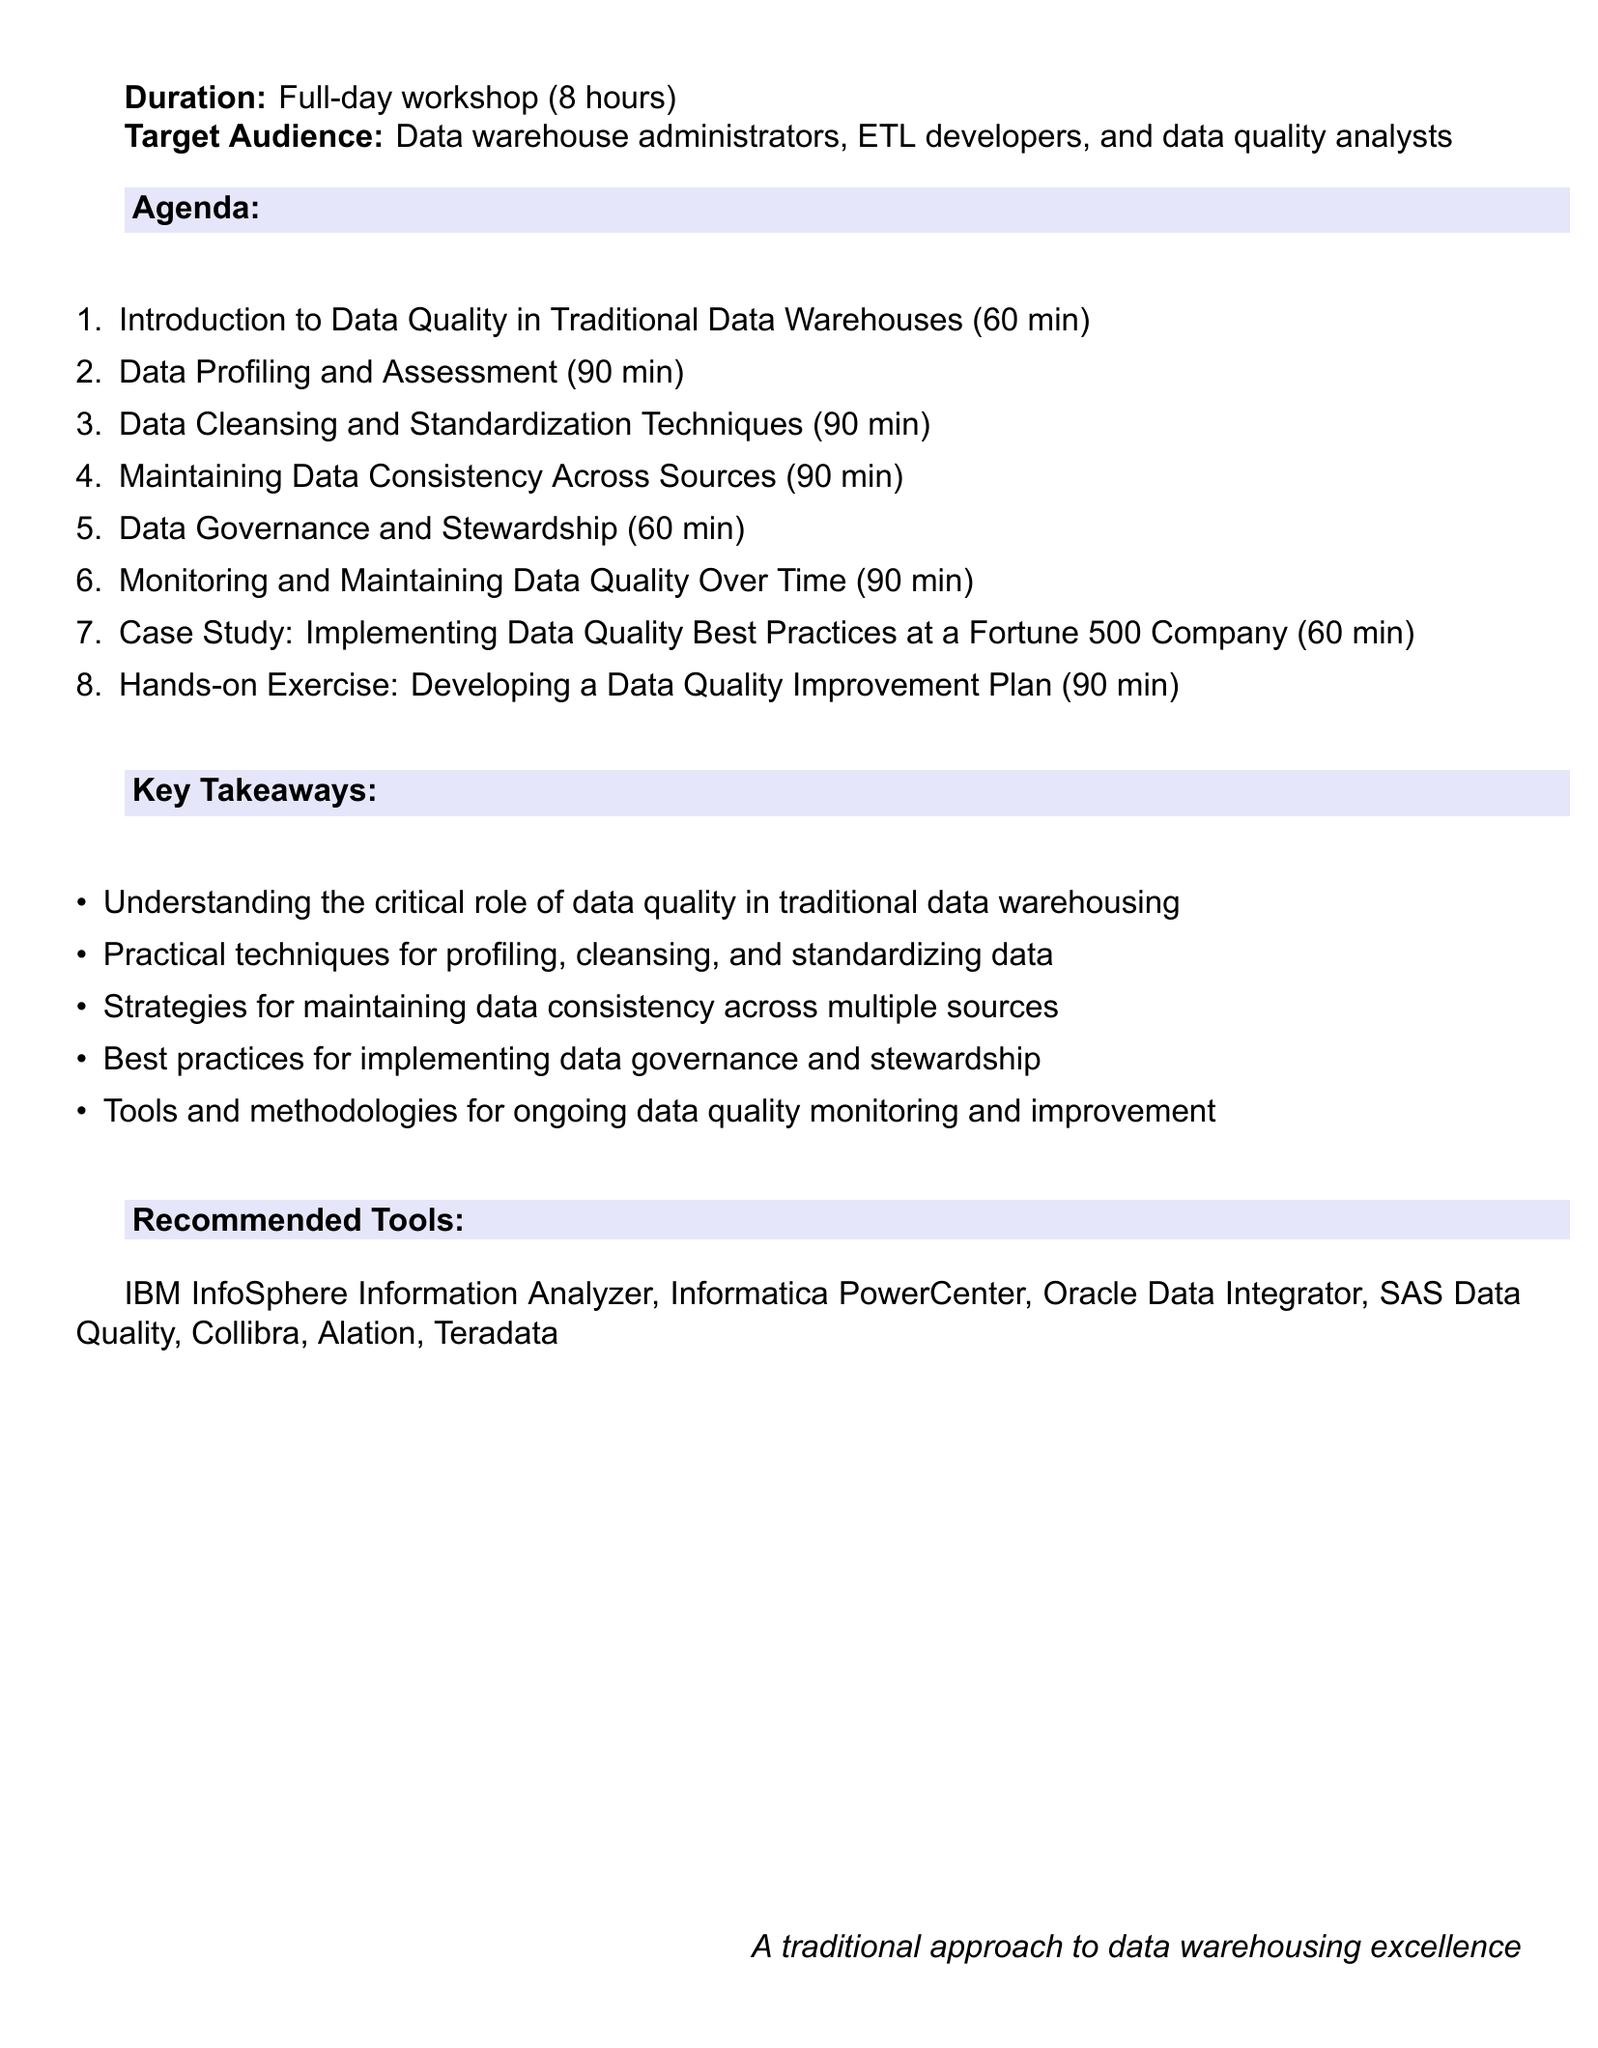What is the duration of the workshop? The document states that the workshop lasts a full day, which is indicated explicitly as 8 hours.
Answer: 8 hours Who is the target audience? The target audience is outlined in the document and includes specific roles related to data management.
Answer: Data warehouse administrators, ETL developers, and data quality analysts How long is the section on Data Governance and Stewardship? The document lists the duration for each section, and this particular section is mentioned to be 60 minutes.
Answer: 60 minutes What is one of the recommended tools for data quality monitoring? The document includes a list of recommended tools, from which one can be extracted.
Answer: IBM InfoSphere Information Analyzer What is a key takeaway from the workshop? The document enumerates multiple key takeaways from the workshop, highlighting the importance of a specific aspect of data warehousing.
Answer: Understanding the critical role of data quality in traditional data warehousing Which section discusses data cleansing techniques? The document specifies various sections, including one dedicated to the subject of data cleansing.
Answer: Data Cleansing and Standardization Techniques What kind of exercise is included in the workshop? The document describes an engaging component of the workshop, referred to as a hands-on exercise, involving practical application.
Answer: Developing a Data Quality Improvement Plan How many minutes is allocated for the case study section? The duration for the case study section is clearly listed in the document as part of the workshop agenda.
Answer: 60 minutes 